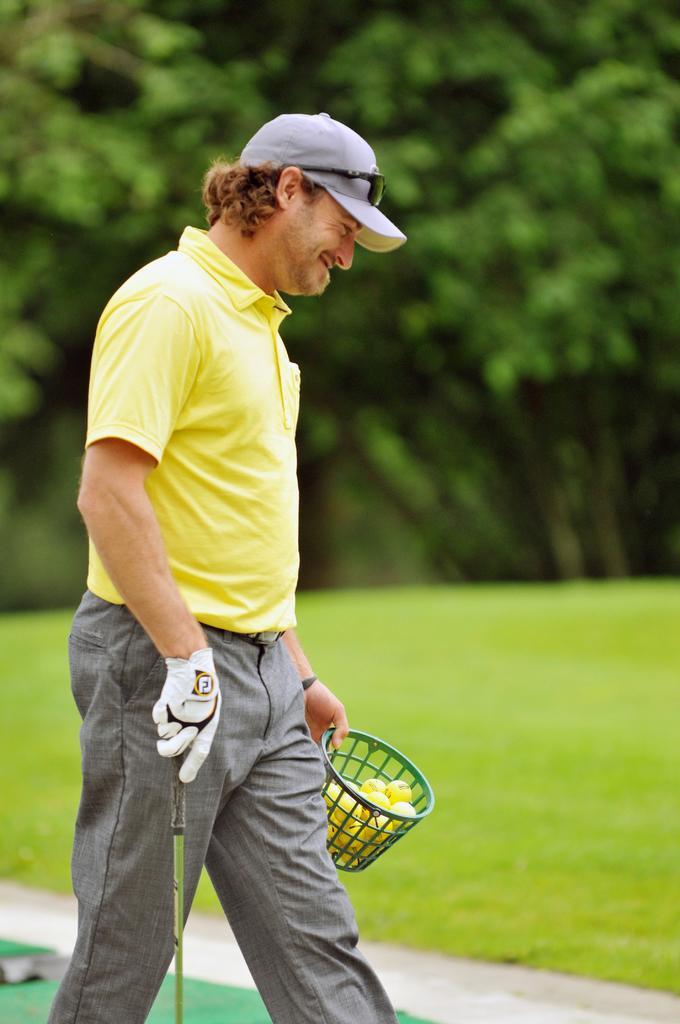Who or what is present in the image? There is a person in the image. What is the person holding in their hands? The person is holding balls and a basket. What else can be seen in the image? There is a stick visible in the image, as well as grass and trees. What type of minute is being used in the image? There is no mention of a minute in the image, as it features a person holding balls and a basket, along with a stick, grass, and trees. 